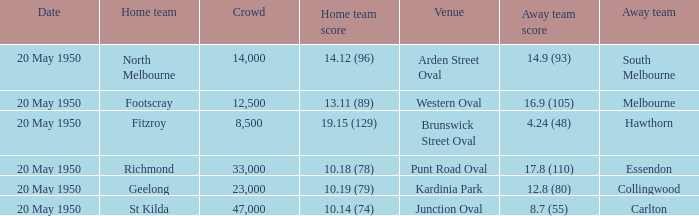What was the largest crowd to view a game where the away team scored 17.8 (110)? 33000.0. 